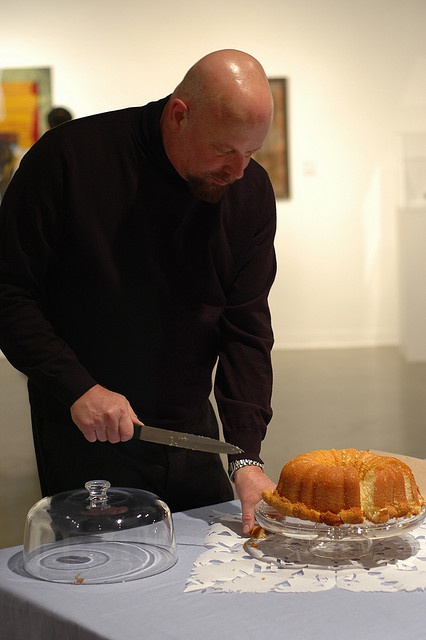Describe the objects in this image and their specific colors. I can see people in tan, black, maroon, and brown tones, dining table in tan, darkgray, lightgray, and gray tones, cake in tan, brown, maroon, and orange tones, bowl in tan, gray, and darkgray tones, and knife in tan, black, and gray tones in this image. 